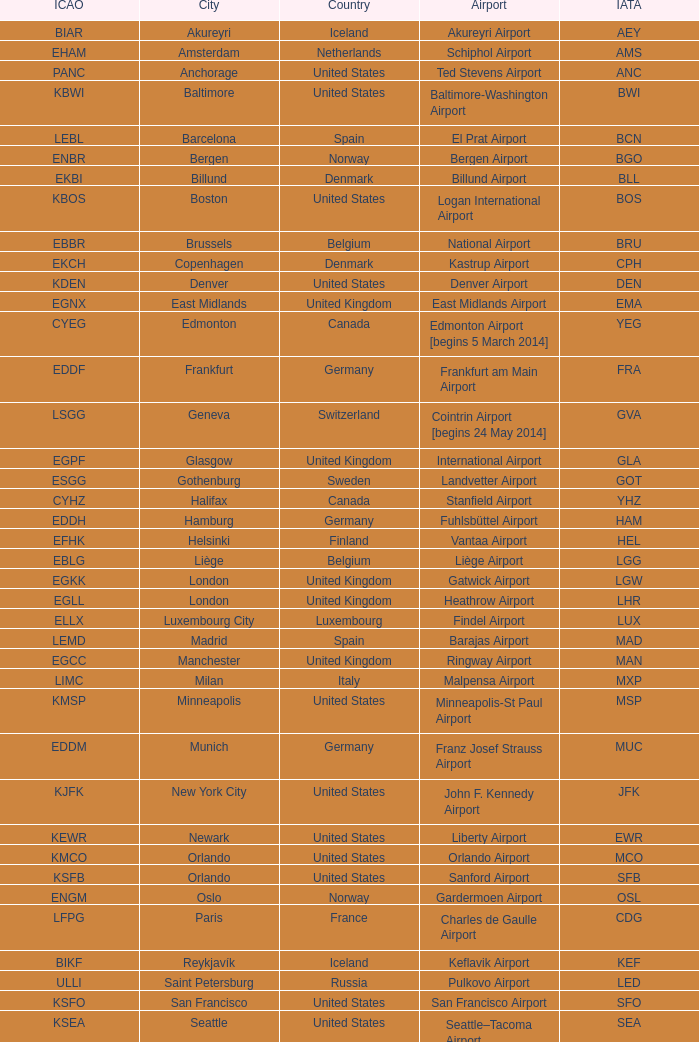What is the Airport with a ICAO of EDDH? Fuhlsbüttel Airport. 